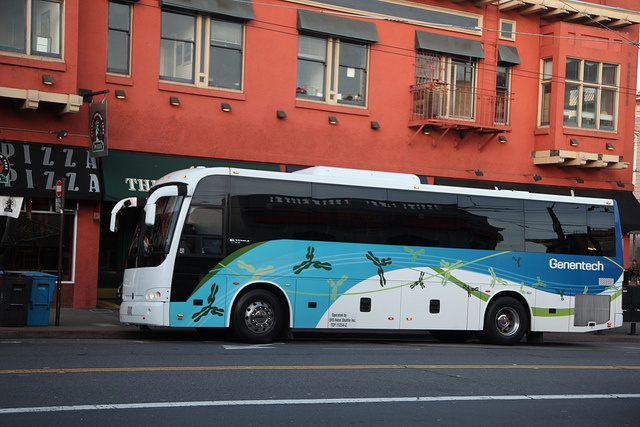Describe the objects in this image and their specific colors. I can see bus in black, lightgray, gray, and teal tones in this image. 